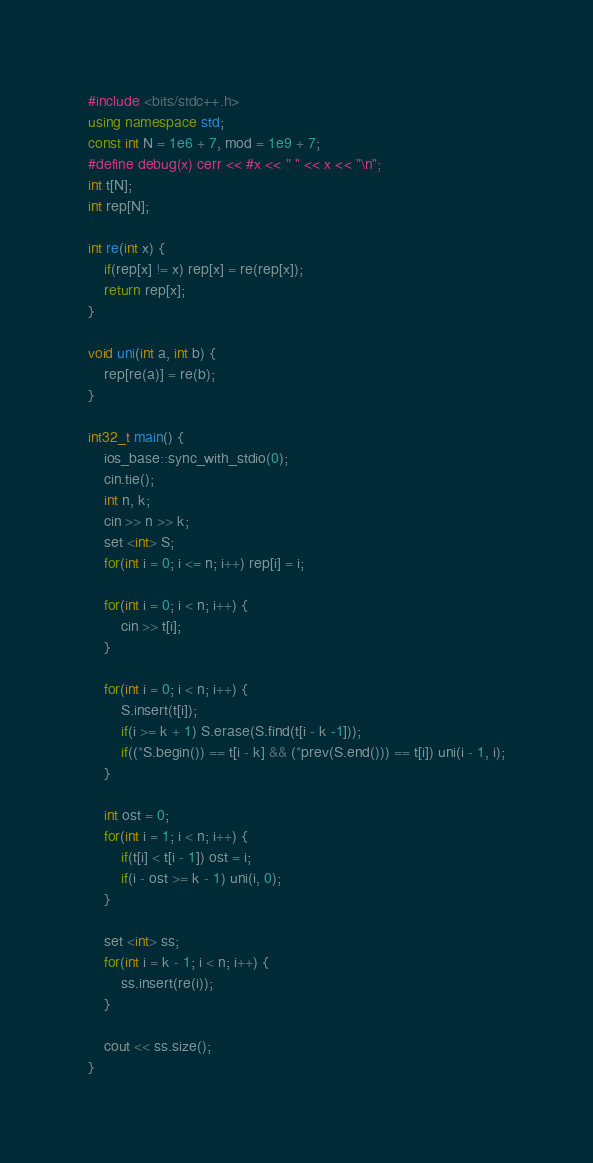<code> <loc_0><loc_0><loc_500><loc_500><_C++_>#include <bits/stdc++.h>
using namespace std;
const int N = 1e6 + 7, mod = 1e9 + 7;
#define debug(x) cerr << #x << " " << x << "\n";
int t[N];
int rep[N];

int re(int x) {
	if(rep[x] != x) rep[x] = re(rep[x]);
	return rep[x];
}

void uni(int a, int b) {
	rep[re(a)] = re(b);
}

int32_t main() {
	ios_base::sync_with_stdio(0);
	cin.tie();
	int n, k;
	cin >> n >> k;
	set <int> S;
	for(int i = 0; i <= n; i++) rep[i] = i;

	for(int i = 0; i < n; i++) {
		cin >> t[i];
	}

	for(int i = 0; i < n; i++) {
		S.insert(t[i]);
		if(i >= k + 1) S.erase(S.find(t[i - k -1]));
		if((*S.begin()) == t[i - k] && (*prev(S.end())) == t[i]) uni(i - 1, i);
	}

	int ost = 0;
	for(int i = 1; i < n; i++) {
		if(t[i] < t[i - 1]) ost = i;
		if(i - ost >= k - 1) uni(i, 0);
	}

	set <int> ss;
	for(int i = k - 1; i < n; i++) {
		ss.insert(re(i));
	}

	cout << ss.size();
}</code> 